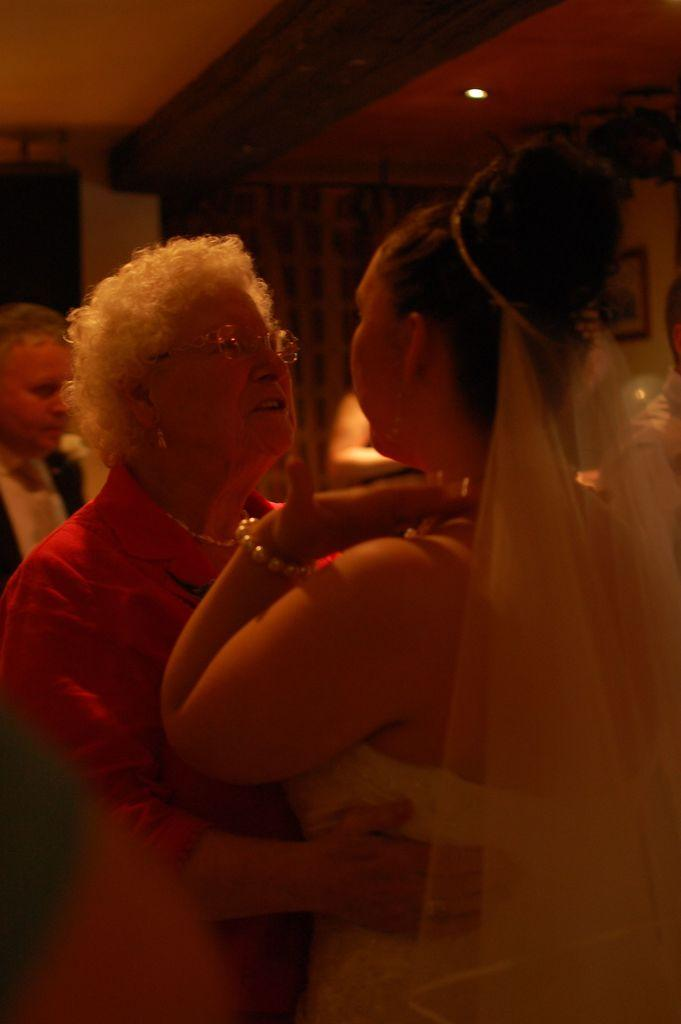What is the main action taking place in the image? There is a person holding a woman in the image. What can be seen on the wall in the image? There is a frame on the wall in the image. Can you describe the background of the image? There are a few people visible in the background of the image. What type of veil is the woman wearing in the image? There is no veil present in the image; the woman is not wearing one. What sense is being evoked by the image? The image does not evoke a specific sense, as it is a still photograph. 